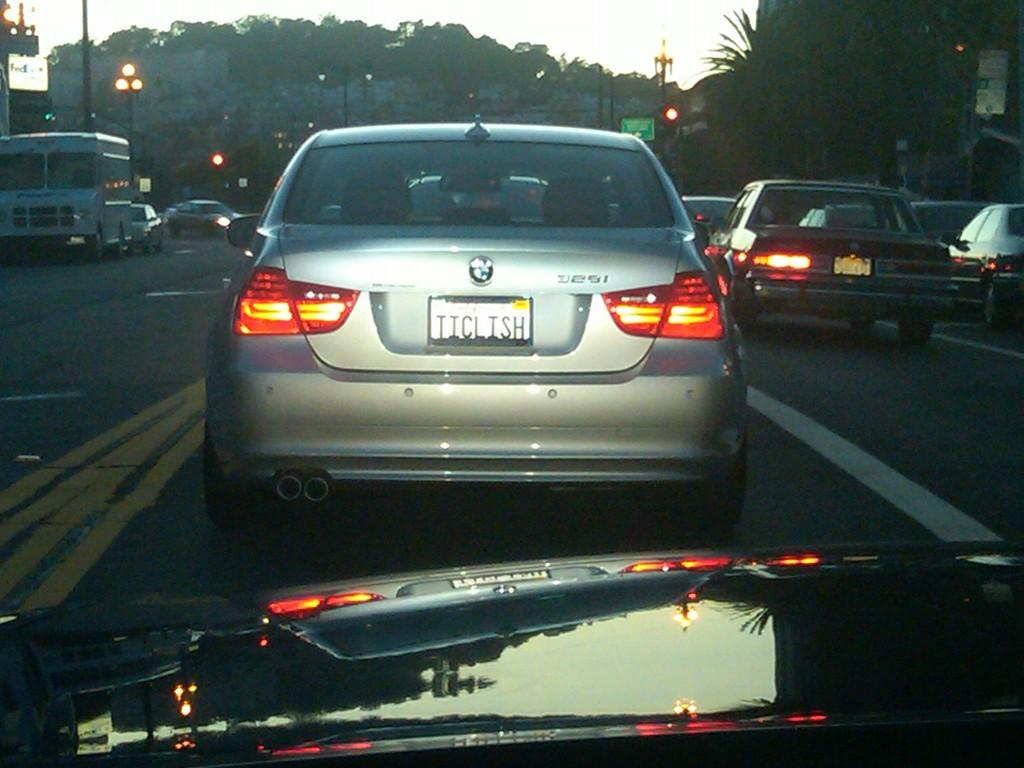<image>
Summarize the visual content of the image. A  silver car with a plate that reads TICLISH. 